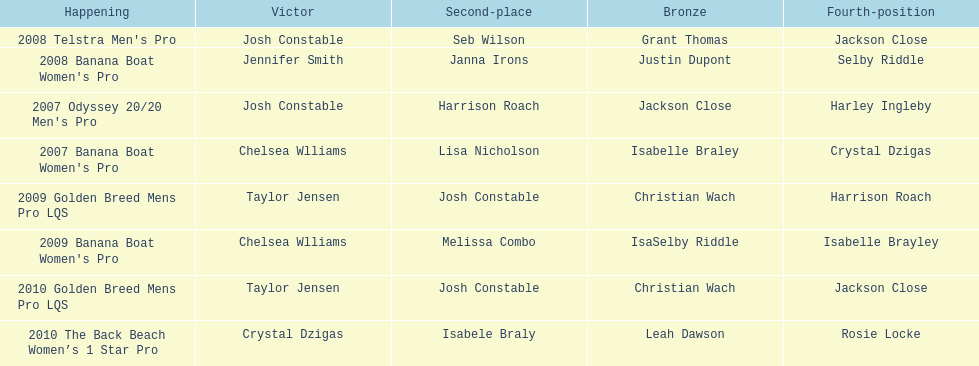How many times was josh constable second? 2. Could you parse the entire table? {'header': ['Happening', 'Victor', 'Second-place', 'Bronze', 'Fourth-position'], 'rows': [["2008 Telstra Men's Pro", 'Josh Constable', 'Seb Wilson', 'Grant Thomas', 'Jackson Close'], ["2008 Banana Boat Women's Pro", 'Jennifer Smith', 'Janna Irons', 'Justin Dupont', 'Selby Riddle'], ["2007 Odyssey 20/20 Men's Pro", 'Josh Constable', 'Harrison Roach', 'Jackson Close', 'Harley Ingleby'], ["2007 Banana Boat Women's Pro", 'Chelsea Wlliams', 'Lisa Nicholson', 'Isabelle Braley', 'Crystal Dzigas'], ['2009 Golden Breed Mens Pro LQS', 'Taylor Jensen', 'Josh Constable', 'Christian Wach', 'Harrison Roach'], ["2009 Banana Boat Women's Pro", 'Chelsea Wlliams', 'Melissa Combo', 'IsaSelby Riddle', 'Isabelle Brayley'], ['2010 Golden Breed Mens Pro LQS', 'Taylor Jensen', 'Josh Constable', 'Christian Wach', 'Jackson Close'], ['2010 The Back Beach Women’s 1 Star Pro', 'Crystal Dzigas', 'Isabele Braly', 'Leah Dawson', 'Rosie Locke']]} 